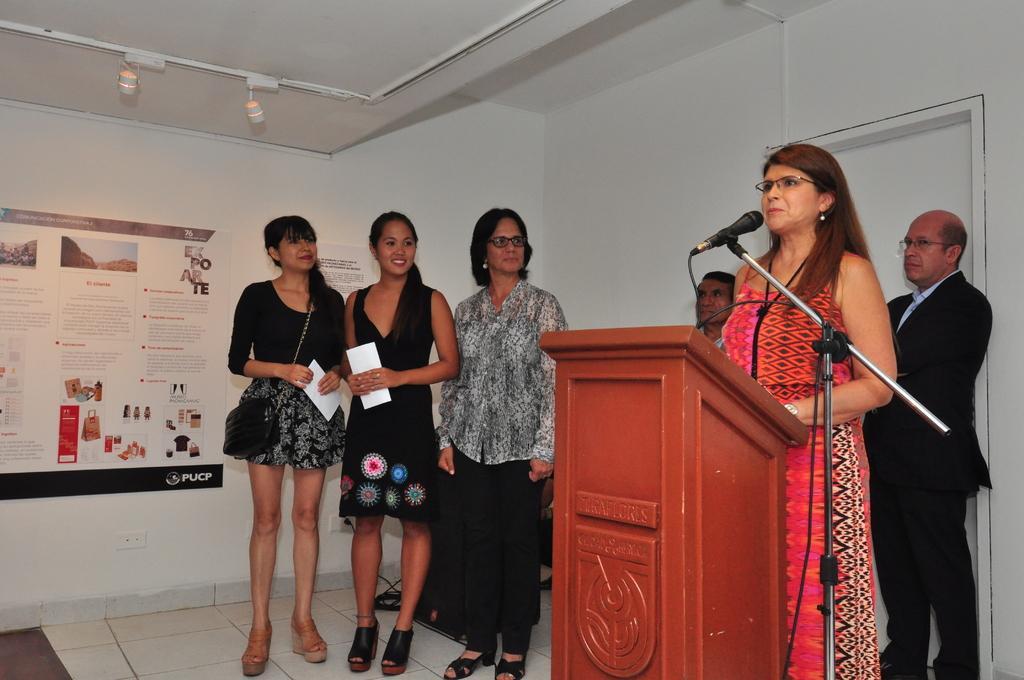In one or two sentences, can you explain what this image depicts? In the picture I can see a woman standing and speaking in front of a mic in the right corner and there is a wooden stand in front of her and there are few other persons behind and beside her and there is a sheet which has few images and something written on it in the left corner. 